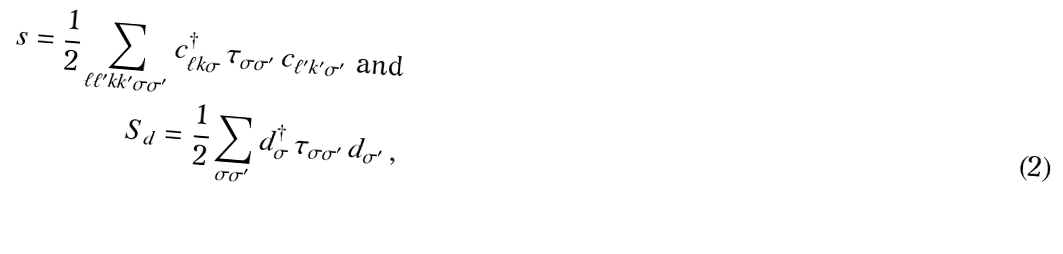Convert formula to latex. <formula><loc_0><loc_0><loc_500><loc_500>s = \frac { 1 } { 2 } \sum _ { \ell \ell ^ { \prime } k k ^ { \prime } \sigma \sigma ^ { \prime } } c ^ { \dagger } _ { \ell k \sigma } \, \tau _ { \sigma \sigma ^ { \prime } } \, c _ { \ell ^ { \prime } k ^ { \prime } \sigma ^ { \prime } } \text { and} \\ S _ { d } = \frac { 1 } { 2 } \sum _ { \sigma \sigma ^ { \prime } } d ^ { \dagger } _ { \sigma } \, \tau _ { \sigma \sigma ^ { \prime } } \, d _ { \sigma ^ { \prime } } \, ,</formula> 